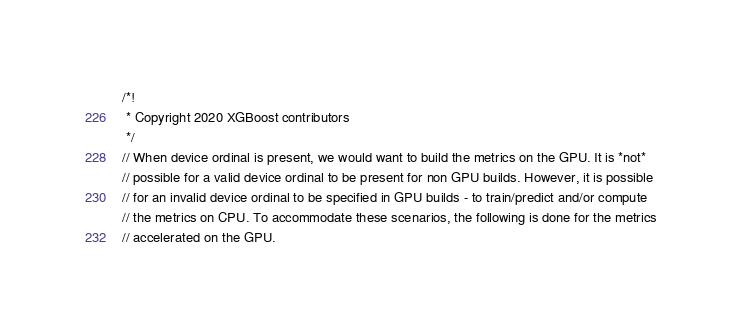Convert code to text. <code><loc_0><loc_0><loc_500><loc_500><_C++_>/*!
 * Copyright 2020 XGBoost contributors
 */
// When device ordinal is present, we would want to build the metrics on the GPU. It is *not*
// possible for a valid device ordinal to be present for non GPU builds. However, it is possible
// for an invalid device ordinal to be specified in GPU builds - to train/predict and/or compute
// the metrics on CPU. To accommodate these scenarios, the following is done for the metrics
// accelerated on the GPU.</code> 